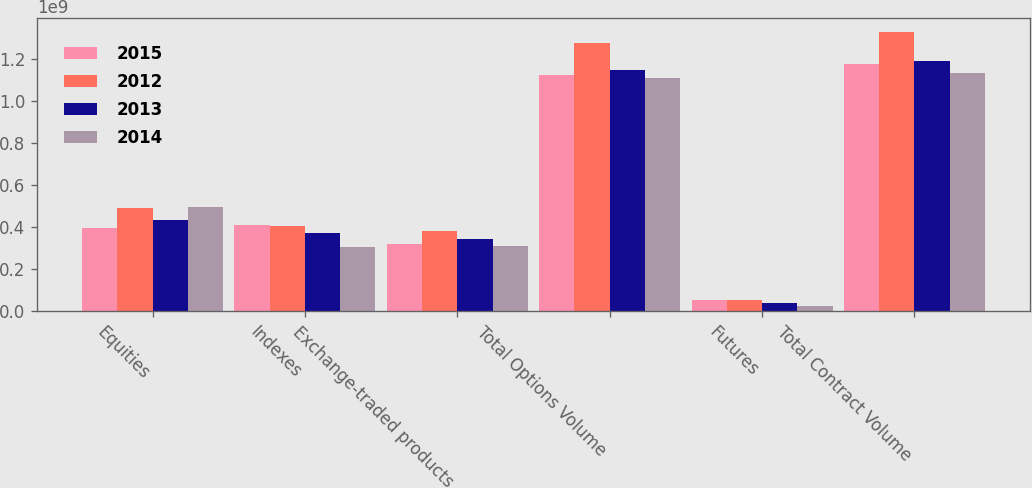Convert chart to OTSL. <chart><loc_0><loc_0><loc_500><loc_500><stacked_bar_chart><ecel><fcel>Equities<fcel>Indexes<fcel>Exchange-traded products<fcel>Total Options Volume<fcel>Futures<fcel>Total Contract Volume<nl><fcel>2015<fcel>3.92982e+08<fcel>4.08282e+08<fcel>3.20997e+08<fcel>1.12226e+09<fcel>5.16712e+07<fcel>1.17393e+09<nl><fcel>2012<fcel>4.88581e+08<fcel>4.06455e+08<fcel>3.79742e+08<fcel>1.27478e+09<fcel>5.06154e+07<fcel>1.32539e+09<nl><fcel>2013<fcel>4.33777e+08<fcel>3.72647e+08<fcel>3.41023e+08<fcel>1.14745e+09<fcel>4.01934e+07<fcel>1.18764e+09<nl><fcel>2014<fcel>4.94289e+08<fcel>3.0434e+08<fcel>3.11792e+08<fcel>1.11042e+09<fcel>2.38929e+07<fcel>1.13431e+09<nl></chart> 